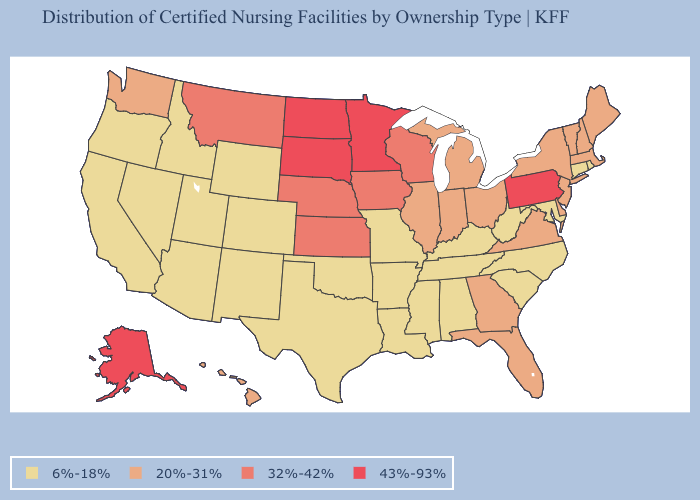What is the highest value in the South ?
Concise answer only. 20%-31%. Which states have the lowest value in the South?
Concise answer only. Alabama, Arkansas, Kentucky, Louisiana, Maryland, Mississippi, North Carolina, Oklahoma, South Carolina, Tennessee, Texas, West Virginia. Among the states that border North Carolina , which have the lowest value?
Concise answer only. South Carolina, Tennessee. Among the states that border Massachusetts , which have the highest value?
Concise answer only. New Hampshire, New York, Vermont. Does Alaska have the highest value in the USA?
Quick response, please. Yes. What is the value of Montana?
Give a very brief answer. 32%-42%. Name the states that have a value in the range 32%-42%?
Keep it brief. Iowa, Kansas, Montana, Nebraska, Wisconsin. What is the lowest value in the MidWest?
Concise answer only. 6%-18%. How many symbols are there in the legend?
Answer briefly. 4. What is the value of Illinois?
Concise answer only. 20%-31%. How many symbols are there in the legend?
Quick response, please. 4. Does Washington have the highest value in the West?
Quick response, please. No. Name the states that have a value in the range 6%-18%?
Keep it brief. Alabama, Arizona, Arkansas, California, Colorado, Connecticut, Idaho, Kentucky, Louisiana, Maryland, Mississippi, Missouri, Nevada, New Mexico, North Carolina, Oklahoma, Oregon, Rhode Island, South Carolina, Tennessee, Texas, Utah, West Virginia, Wyoming. What is the value of Kansas?
Write a very short answer. 32%-42%. Which states have the highest value in the USA?
Concise answer only. Alaska, Minnesota, North Dakota, Pennsylvania, South Dakota. 